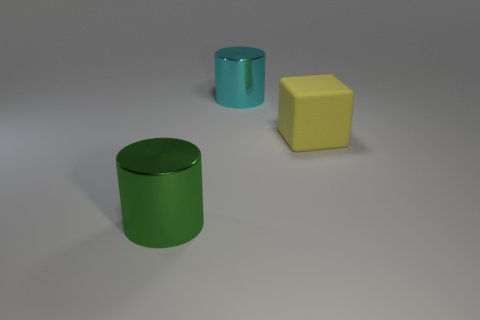What time of day does the lighting in this scene suggest? The soft shadows and even lighting in this image suggest an indoor setting with artificial light, possibly overhead, making it difficult to determine the time of day based on the lighting alone. 